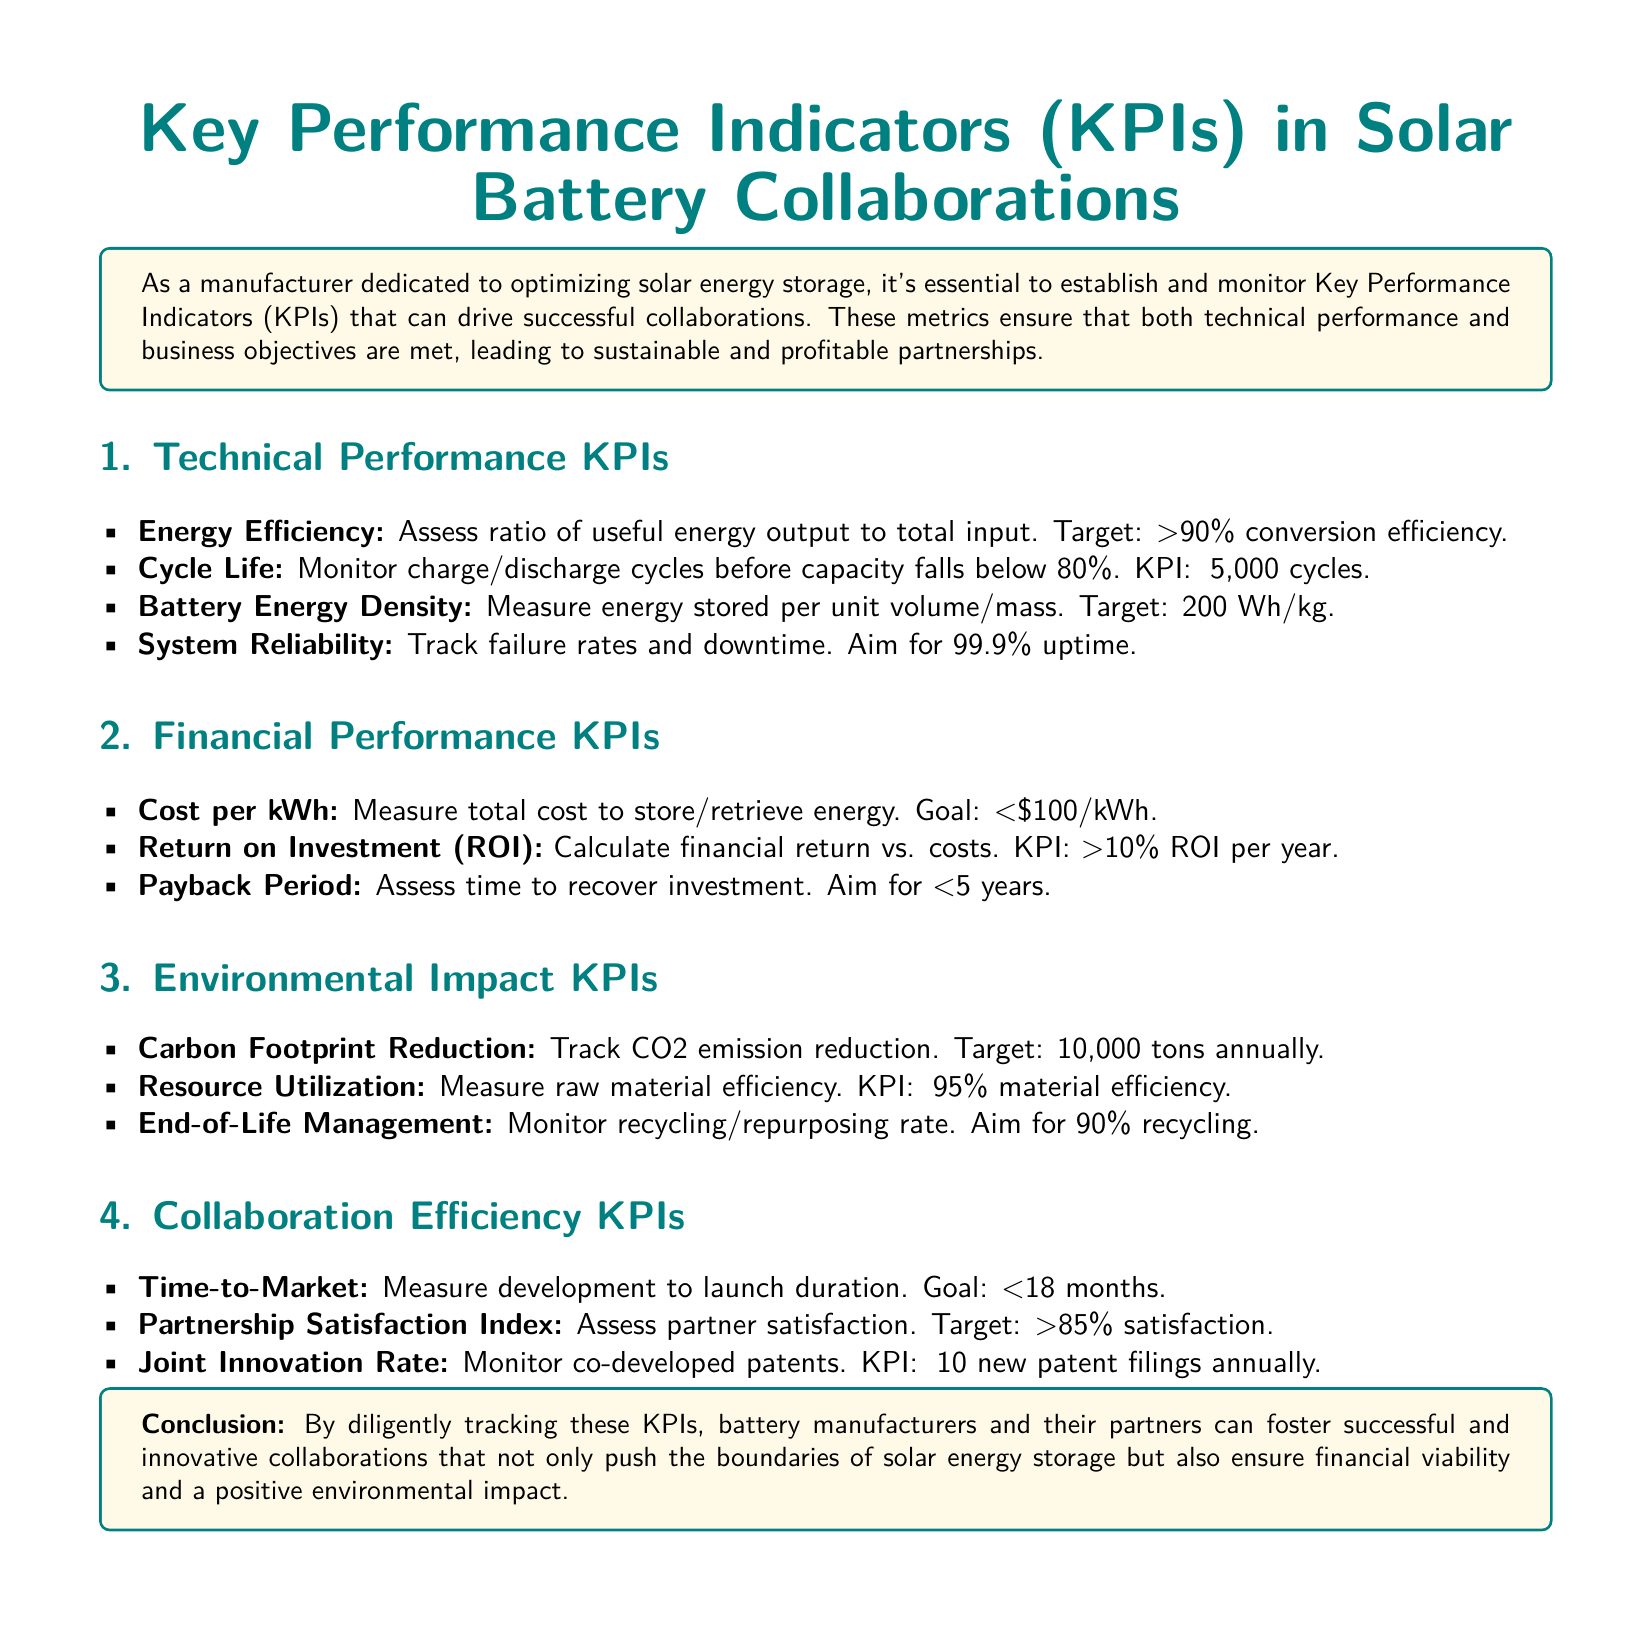what is the target energy efficiency? The document states that the target energy efficiency is >90% conversion efficiency.
Answer: >90% how many cycles should the cycle life KPI meet? The KPI for cycle life is stated to be ≥5,000 cycles in the document.
Answer: ≥5,000 cycles what is the target cost per kWh? The document specifies that the goal for cost per kWh is <$100/kWh.
Answer: <$100/kWh what should the carbon footprint reduction target be? The target for carbon footprint reduction is mentioned as 10,000 tons annually.
Answer: 10,000 tons what is the aim for the payback period? The document indicates that the aim for the payback period is <5 years.
Answer: <5 years what is the goal for time-to-market in months? The document outlines the goal for time-to-market to be <18 months.
Answer: <18 months what is the target for the partnership satisfaction index? The document states that the target for partnership satisfaction index is >85% satisfaction.
Answer: >85% how many new patent filings should be targeted annually? The document mentions the KPI for joint innovation rate is ≥10 new patent filings annually.
Answer: ≥10 